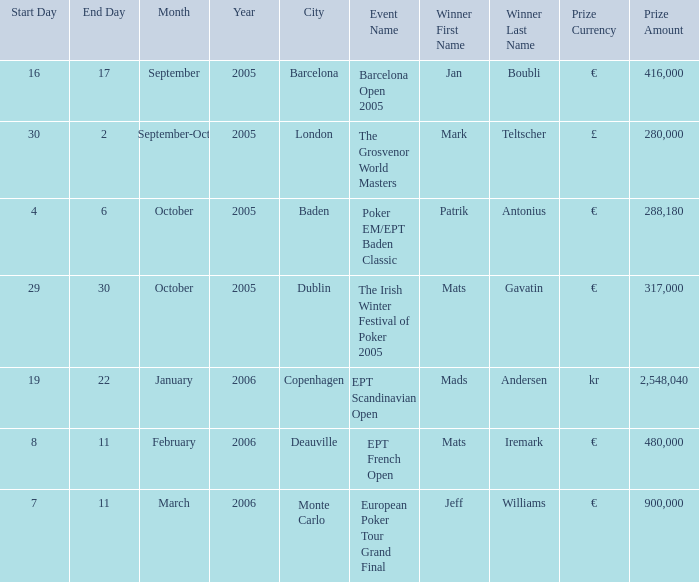What event had a prize of €900,000? European Poker Tour Grand Final. Help me parse the entirety of this table. {'header': ['Start Day', 'End Day', 'Month', 'Year', 'City', 'Event Name', 'Winner First Name', 'Winner Last Name', 'Prize Currency', 'Prize Amount'], 'rows': [['16', '17', 'September', '2005', 'Barcelona', 'Barcelona Open 2005', 'Jan', 'Boubli', '€', '416,000'], ['30', '2', 'September-Oct', '2005', 'London', 'The Grosvenor World Masters', 'Mark', 'Teltscher', '£', '280,000'], ['4', '6', 'October', '2005', 'Baden', 'Poker EM/EPT Baden Classic', 'Patrik', 'Antonius', '€', '288,180'], ['29', '30', 'October', '2005', 'Dublin', 'The Irish Winter Festival of Poker 2005', 'Mats', 'Gavatin', '€', '317,000'], ['19', '22', 'January', '2006', 'Copenhagen', 'EPT Scandinavian Open', 'Mads', 'Andersen', 'kr', '2,548,040'], ['8', '11', 'February', '2006', 'Deauville', 'EPT French Open', 'Mats', 'Iremark', '€', '480,000'], ['7', '11', 'March', '2006', 'Monte Carlo', 'European Poker Tour Grand Final', 'Jeff', 'Williams', '€', '900,000']]} 